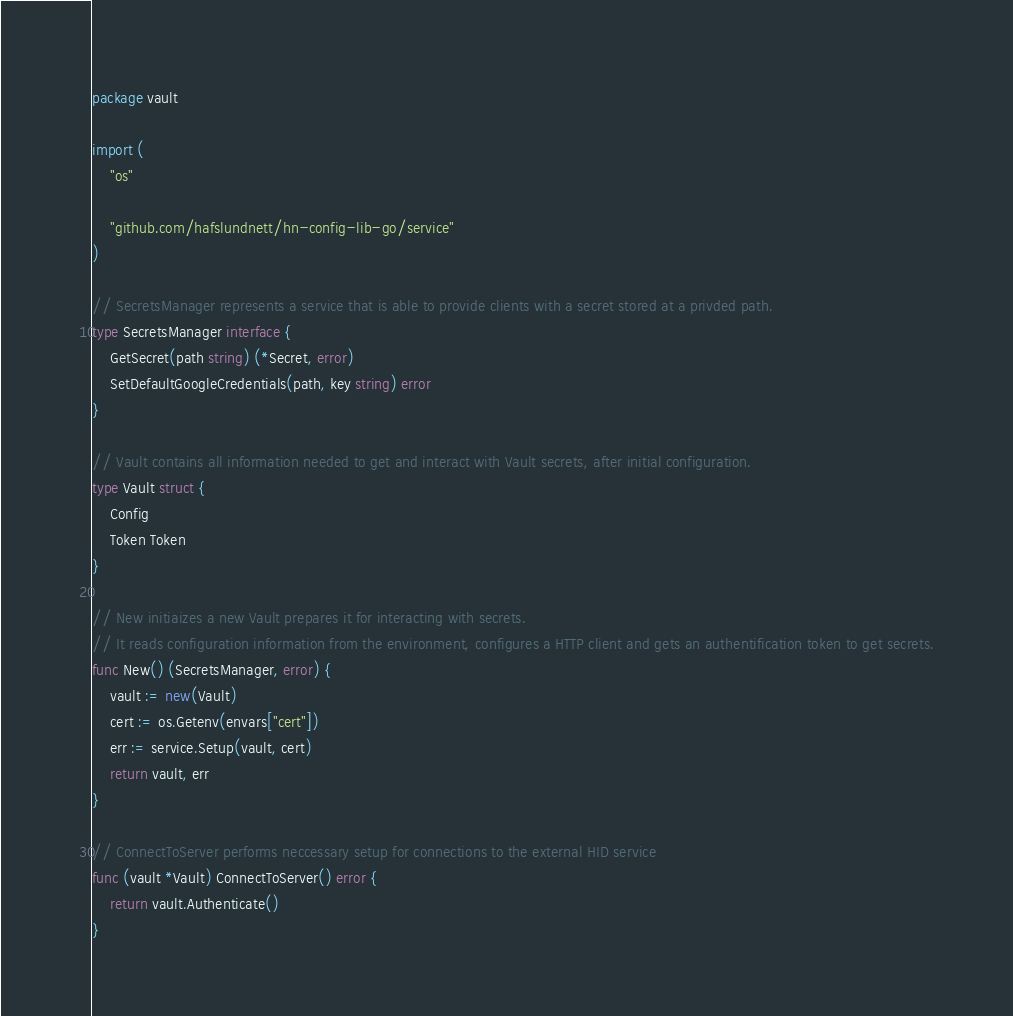Convert code to text. <code><loc_0><loc_0><loc_500><loc_500><_Go_>package vault

import (
	"os"

	"github.com/hafslundnett/hn-config-lib-go/service"
)

// SecretsManager represents a service that is able to provide clients with a secret stored at a privded path.
type SecretsManager interface {
	GetSecret(path string) (*Secret, error)
	SetDefaultGoogleCredentials(path, key string) error
}

// Vault contains all information needed to get and interact with Vault secrets, after initial configuration.
type Vault struct {
	Config
	Token Token
}

// New initiaizes a new Vault prepares it for interacting with secrets.
// It reads configuration information from the environment, configures a HTTP client and gets an authentification token to get secrets.
func New() (SecretsManager, error) {
	vault := new(Vault)
	cert := os.Getenv(envars["cert"])
	err := service.Setup(vault, cert)
	return vault, err
}

// ConnectToServer performs neccessary setup for connections to the external HID service
func (vault *Vault) ConnectToServer() error {
	return vault.Authenticate()
}
</code> 